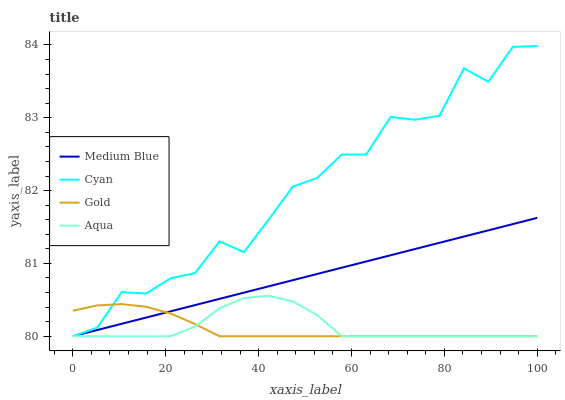Does Gold have the minimum area under the curve?
Answer yes or no. Yes. Does Cyan have the maximum area under the curve?
Answer yes or no. Yes. Does Medium Blue have the minimum area under the curve?
Answer yes or no. No. Does Medium Blue have the maximum area under the curve?
Answer yes or no. No. Is Medium Blue the smoothest?
Answer yes or no. Yes. Is Cyan the roughest?
Answer yes or no. Yes. Is Cyan the smoothest?
Answer yes or no. No. Is Medium Blue the roughest?
Answer yes or no. No. Does Aqua have the lowest value?
Answer yes or no. Yes. Does Cyan have the highest value?
Answer yes or no. Yes. Does Medium Blue have the highest value?
Answer yes or no. No. Does Gold intersect Aqua?
Answer yes or no. Yes. Is Gold less than Aqua?
Answer yes or no. No. Is Gold greater than Aqua?
Answer yes or no. No. 